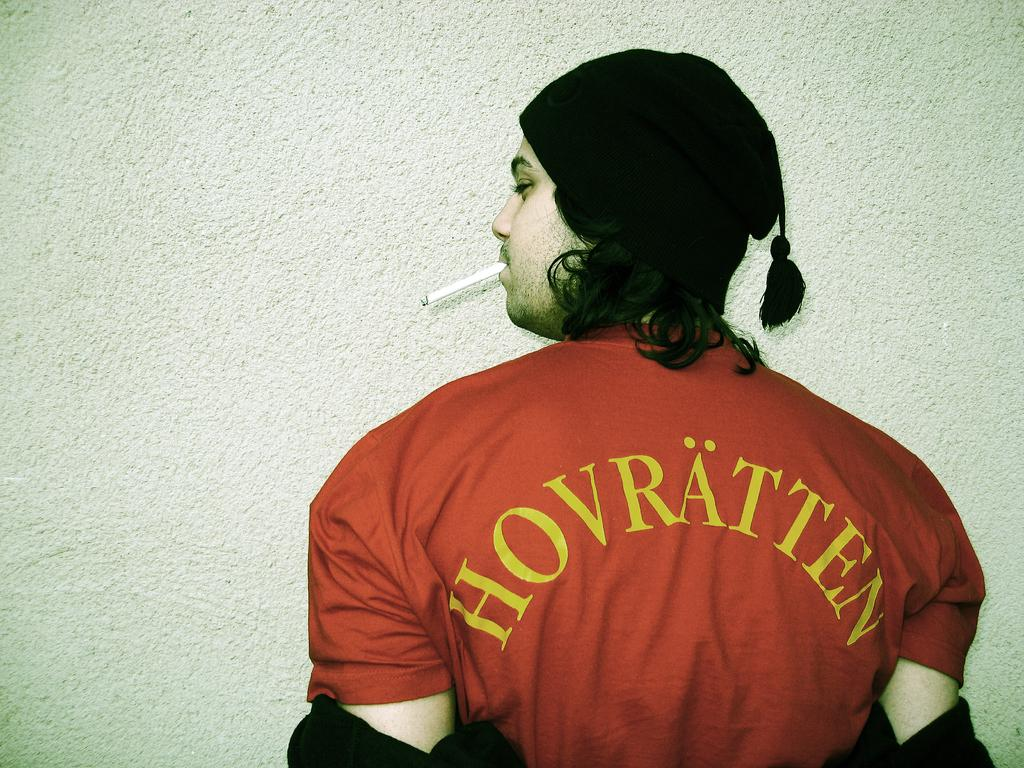<image>
Write a terse but informative summary of the picture. A man smoking a cigarette is wearing a red shirt with yellow lettering that says "Hovratten". 